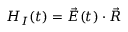Convert formula to latex. <formula><loc_0><loc_0><loc_500><loc_500>H _ { I } ( t ) = \vec { E } ( t ) \cdot \vec { R }</formula> 